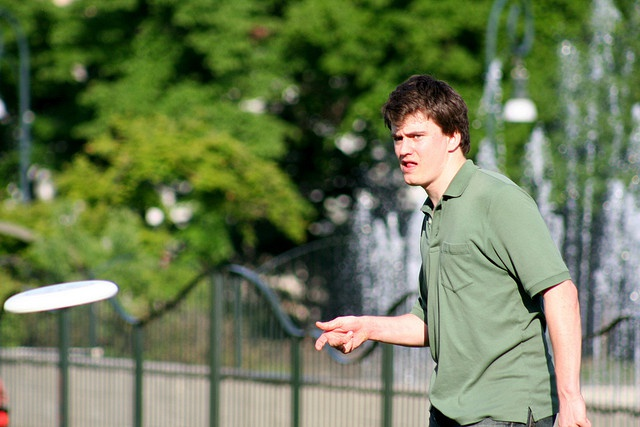Describe the objects in this image and their specific colors. I can see people in darkgreen, darkgray, lightgray, beige, and black tones, frisbee in darkgreen, white, darkgray, brown, and gray tones, and parking meter in darkgreen, darkgray, gray, and lightgray tones in this image. 